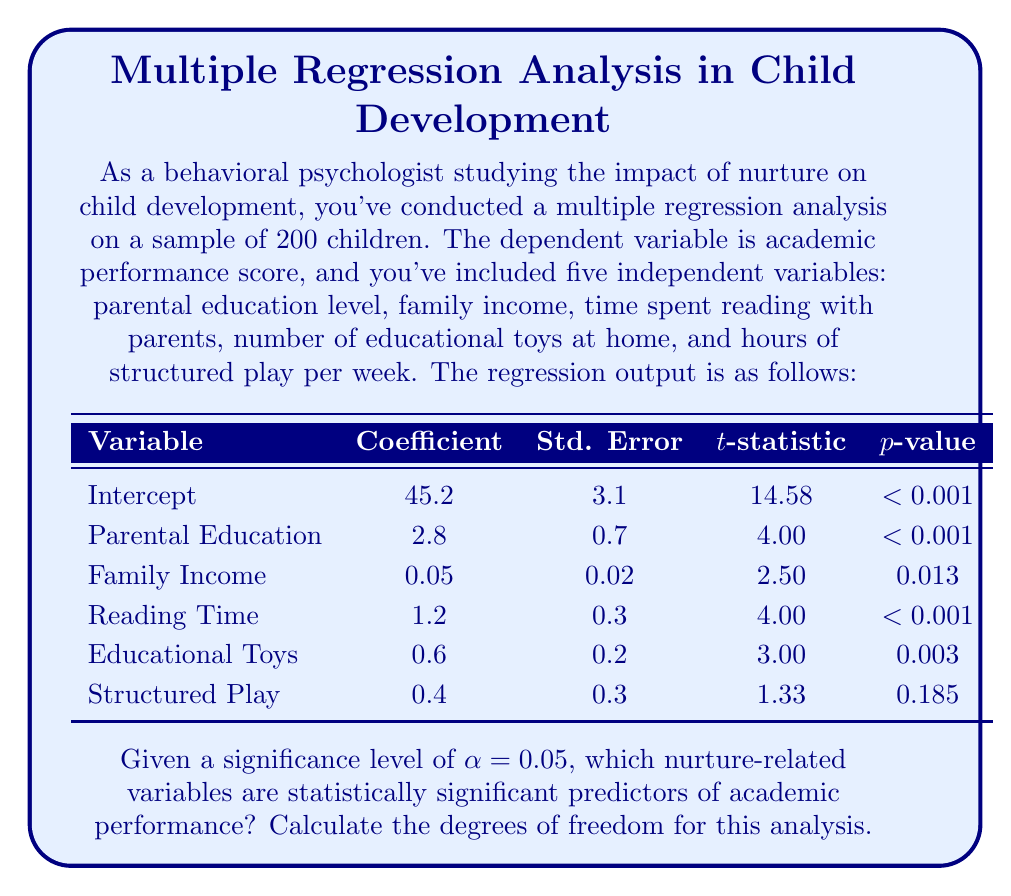Can you answer this question? To determine which nurture-related variables are statistically significant predictors of academic performance, we need to compare each variable's p-value to the given significance level (α = 0.05). If a variable's p-value is less than α, it is considered statistically significant.

Step 1: Compare p-values to α = 0.05
- Parental Education: p < 0.001 < 0.05 (Significant)
- Family Income: p = 0.013 < 0.05 (Significant)
- Reading Time: p < 0.001 < 0.05 (Significant)
- Educational Toys: p = 0.003 < 0.05 (Significant)
- Structured Play: p = 0.185 > 0.05 (Not Significant)

Step 2: Calculate degrees of freedom (df)
In multiple regression, df = n - k - 1, where:
n = number of observations
k = number of independent variables

Given:
n = 200 (sample size)
k = 5 (number of independent variables)

df = 200 - 5 - 1 = 194

Therefore, four out of five nurture-related variables (Parental Education, Family Income, Reading Time, and Educational Toys) are statistically significant predictors of academic performance. The degrees of freedom for this analysis is 194.
Answer: Significant predictors: Parental Education, Family Income, Reading Time, Educational Toys. df = 194. 